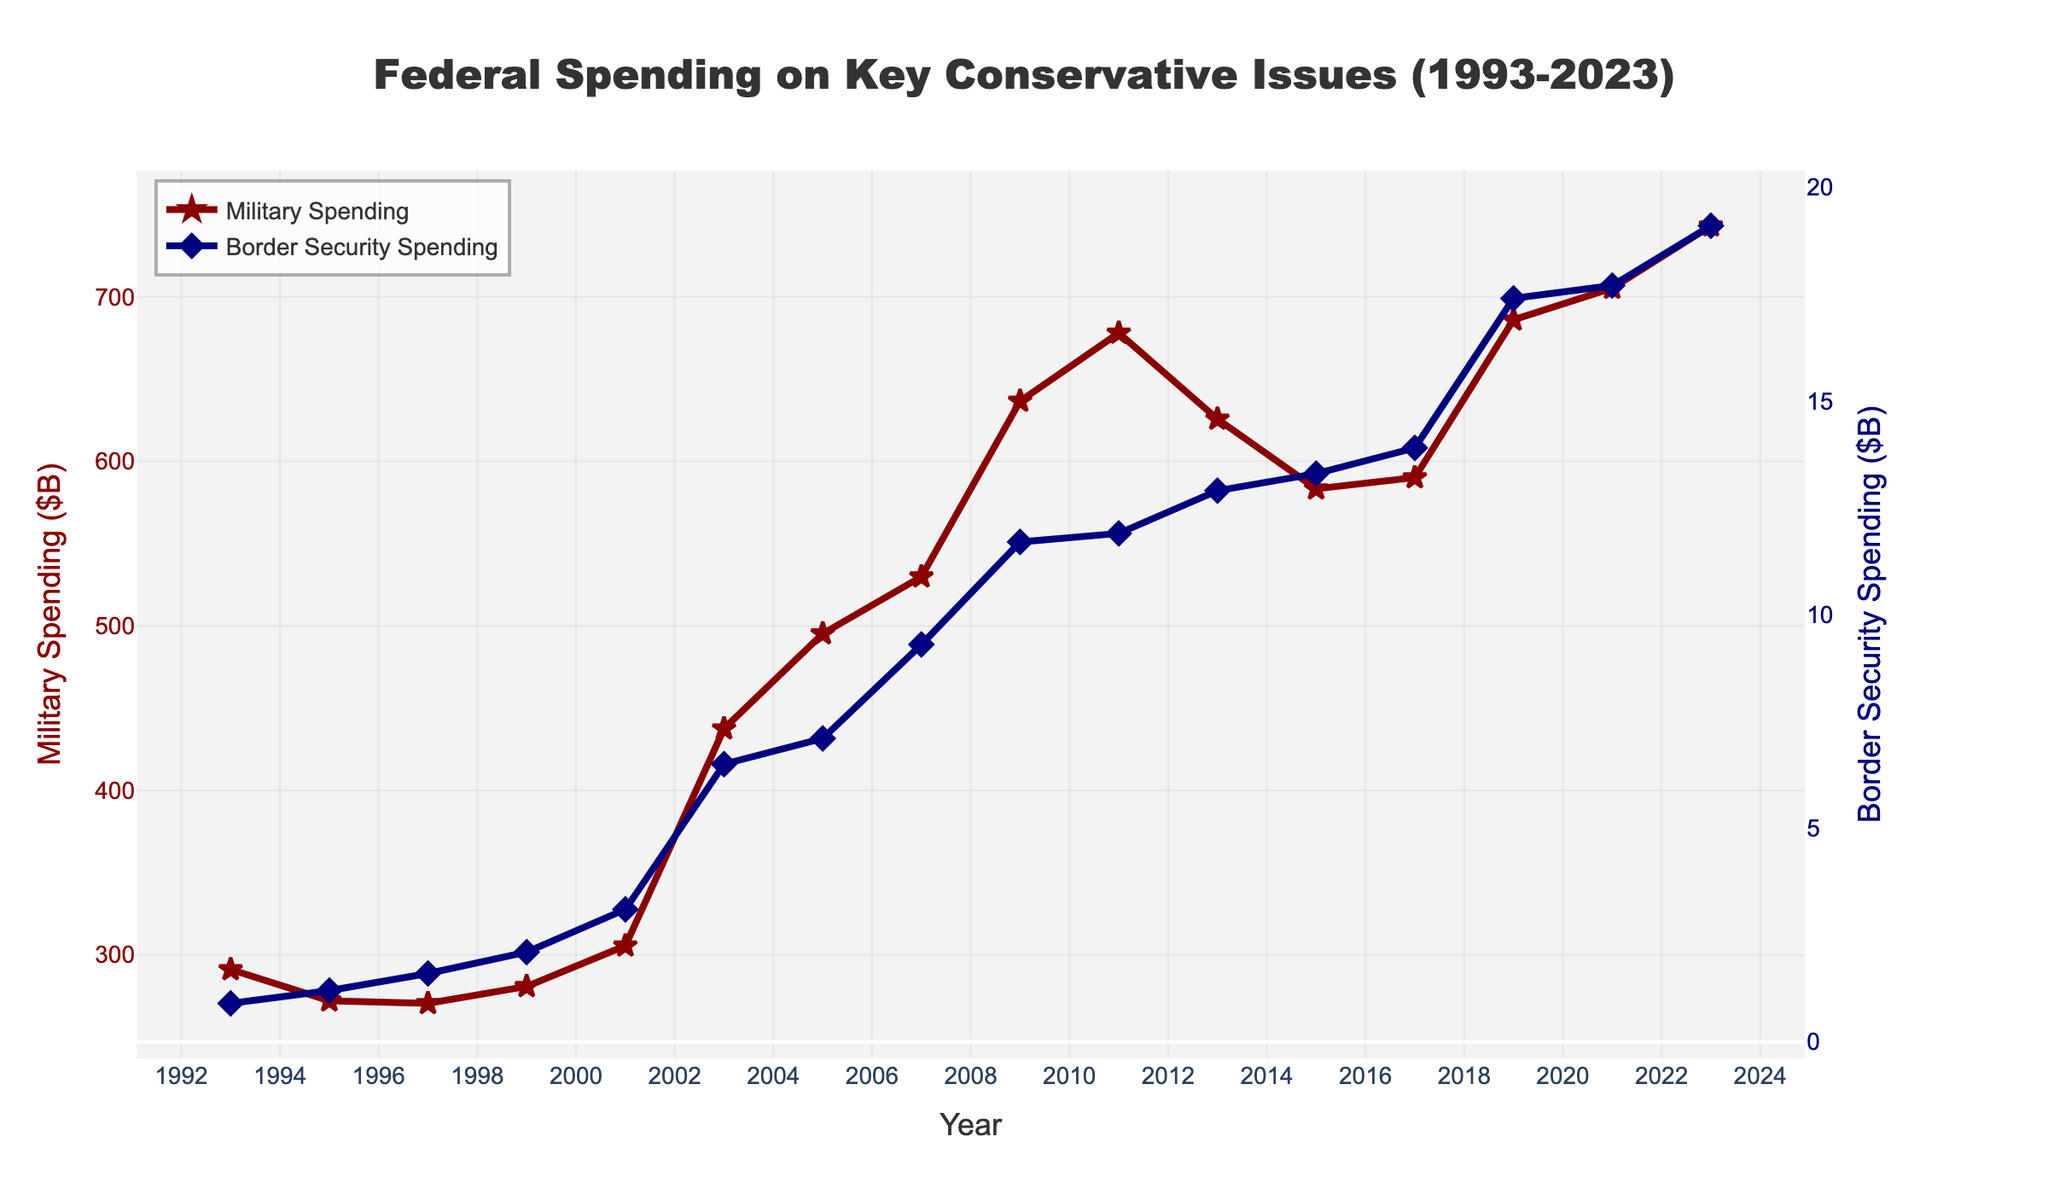What was the military spending in 1993? To find the military spending in 1993, look at the first data point on the red line representing military spending.
Answer: 291.1 billion dollars How much did border security spending increase from 2001 to 2003? To find the increase, subtract the 2001 value (3.1 billion dollars) from the 2003 value (6.5 billion dollars).
Answer: 3.4 billion dollars In which year did military spending cross 700 billion dollars? Look at the red line and find the year when the value exceeded 700 billion dollars.
Answer: 2021 Compare the increase in military spending and border security spending from 1993 to 2023. Subtract the 1993 values from the 2023 values for both military spending (743.3 - 291.1 = 452.2 billion dollars) and border security spending (19.1 - 0.9 = 18.2 billion dollars).
Answer: Military: 452.2 billion dollars, Border Security: 18.2 billion dollars What was the highest spending on border security shown in the graph, and in which year did it occur? Identify the peak value on the blue line representing border security spending and note the corresponding year.
Answer: 19.1 billion dollars in 2023 Did military spending ever decrease over a period of two consecutive years? If so, when? Observe the red line and identify if there are any years when military spending decreased compared to the previous year.
Answer: Yes, from 1993 to 1995 and from 2011 to 2013 What is the average military spending over the first ten years (1993-2003)? Sum the military spending values from 1993 to 2003 and divide by the number of years (10). (291.1 + 272.1 + 270.5 + 280.8 + 305.5 + 437.5 + 495.3 + 529.9 + 636.7 + 678.1) / 10
Answer: 419.75 billion dollars Between military and border security spending, which saw a higher absolute increase between 2019 and 2023, and by how much? Subtract the 2019 values from the 2023 values for both military (743.3 - 686.1) and border security (19.1 - 17.4), then compare the increases.
Answer: Military increased by 57.2 billion dollars, Border Security increased by 1.7 billion dollars; Military saw a higher increase What visual indicator distinguishes military spending from border security spending in the chart? Describe the colors and line markers used for each spending category.
Answer: Military spending is depicted with a red line and star markers, while border security spending is depicted with a blue line and diamond markers 